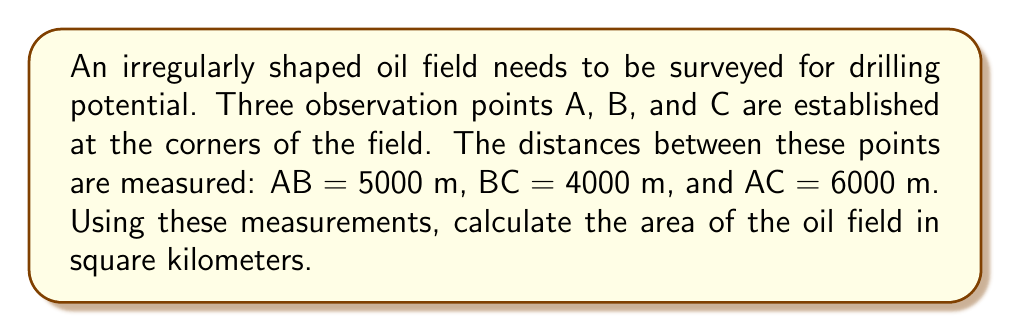Can you answer this question? To find the area of the irregularly shaped oil field, we can use Heron's formula, which calculates the area of a triangle given the lengths of its three sides.

Step 1: Identify the sides of the triangle
Let a = 5000 m (AB), b = 4000 m (BC), and c = 6000 m (AC)

Step 2: Calculate the semi-perimeter (s)
$$s = \frac{a + b + c}{2} = \frac{5000 + 4000 + 6000}{2} = 7500 \text{ m}$$

Step 3: Apply Heron's formula
The area (A) of a triangle using Heron's formula is:
$$A = \sqrt{s(s-a)(s-b)(s-c)}$$

Substituting the values:
$$A = \sqrt{7500(7500-5000)(7500-4000)(7500-6000)}$$
$$A = \sqrt{7500 \cdot 2500 \cdot 3500 \cdot 1500}$$
$$A = \sqrt{98,437,500,000,000}$$
$$A = 9,921,567.42 \text{ m}^2$$

Step 4: Convert the area to square kilometers
$$A = 9,921,567.42 \text{ m}^2 \cdot \frac{1 \text{ km}^2}{1,000,000 \text{ m}^2} = 9.92 \text{ km}^2$$

[asy]
unitsize(0.0001 cm);
pair A = (0,0), B = (5000,0), C = (3000,4000);
draw(A--B--C--A);
label("A", A, SW);
label("B", B, SE);
label("C", C, N);
label("5000 m", (A+B)/2, S);
label("4000 m", (B+C)/2, NE);
label("6000 m", (A+C)/2, NW);
[/asy]
Answer: 9.92 km² 